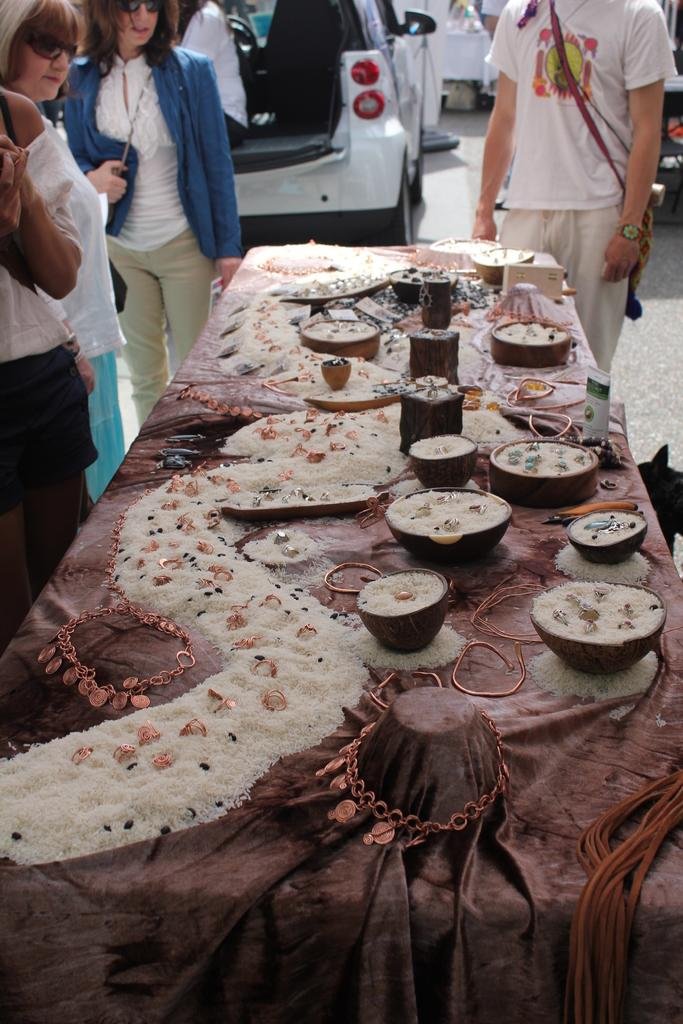Where is the photo taken? The photo is taken in the middle of a road. What can be seen on the table in the image? There are grains, chains, and bowls on the table. What is the purpose of the chains on the table? The purpose of the chains on the table is not clear from the image, but they are likely used to hold or secure something. How many people are standing around the table? There are people standing around the table in the image. What can be seen in the background of the image? There are cars and people in the background of the image. What type of crime is being committed in the image? There is no indication of a crime being committed in the image. 